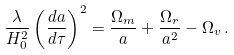Convert formula to latex. <formula><loc_0><loc_0><loc_500><loc_500>\frac { \lambda } { H _ { 0 } ^ { 2 } } \left ( { \frac { d a } { d \tau } } \right ) ^ { 2 } = \frac { \Omega _ { m } } { a } + \frac { \Omega _ { r } } { a ^ { 2 } } - \Omega _ { v } \, .</formula> 